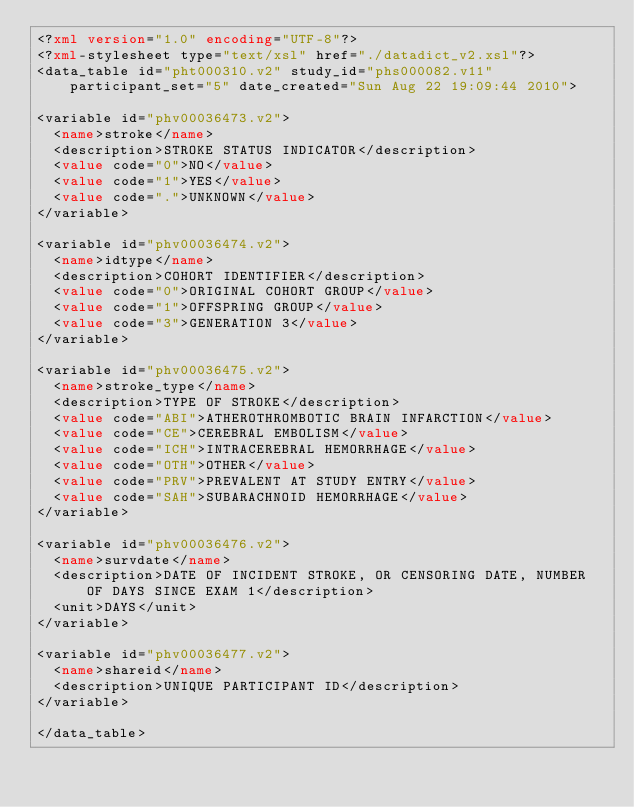<code> <loc_0><loc_0><loc_500><loc_500><_XML_><?xml version="1.0" encoding="UTF-8"?>
<?xml-stylesheet type="text/xsl" href="./datadict_v2.xsl"?>
<data_table id="pht000310.v2" study_id="phs000082.v11" participant_set="5" date_created="Sun Aug 22 19:09:44 2010">

<variable id="phv00036473.v2">
	<name>stroke</name>
	<description>STROKE STATUS INDICATOR</description>
	<value code="0">NO</value>
	<value code="1">YES</value>
	<value code=".">UNKNOWN</value>
</variable>

<variable id="phv00036474.v2">
	<name>idtype</name>
	<description>COHORT IDENTIFIER</description>
	<value code="0">ORIGINAL COHORT GROUP</value>
	<value code="1">OFFSPRING GROUP</value>
	<value code="3">GENERATION 3</value>
</variable>

<variable id="phv00036475.v2">
	<name>stroke_type</name>
	<description>TYPE OF STROKE</description>
	<value code="ABI">ATHEROTHROMBOTIC BRAIN INFARCTION</value>
	<value code="CE">CEREBRAL EMBOLISM</value>
	<value code="ICH">INTRACEREBRAL HEMORRHAGE</value>
	<value code="OTH">OTHER</value>
	<value code="PRV">PREVALENT AT STUDY ENTRY</value>
	<value code="SAH">SUBARACHNOID HEMORRHAGE</value>
</variable>

<variable id="phv00036476.v2">
	<name>survdate</name>
	<description>DATE OF INCIDENT STROKE, OR CENSORING DATE, NUMBER OF DAYS SINCE EXAM 1</description>
	<unit>DAYS</unit>
</variable>

<variable id="phv00036477.v2">
	<name>shareid</name>
	<description>UNIQUE PARTICIPANT ID</description>
</variable>

</data_table>
</code> 